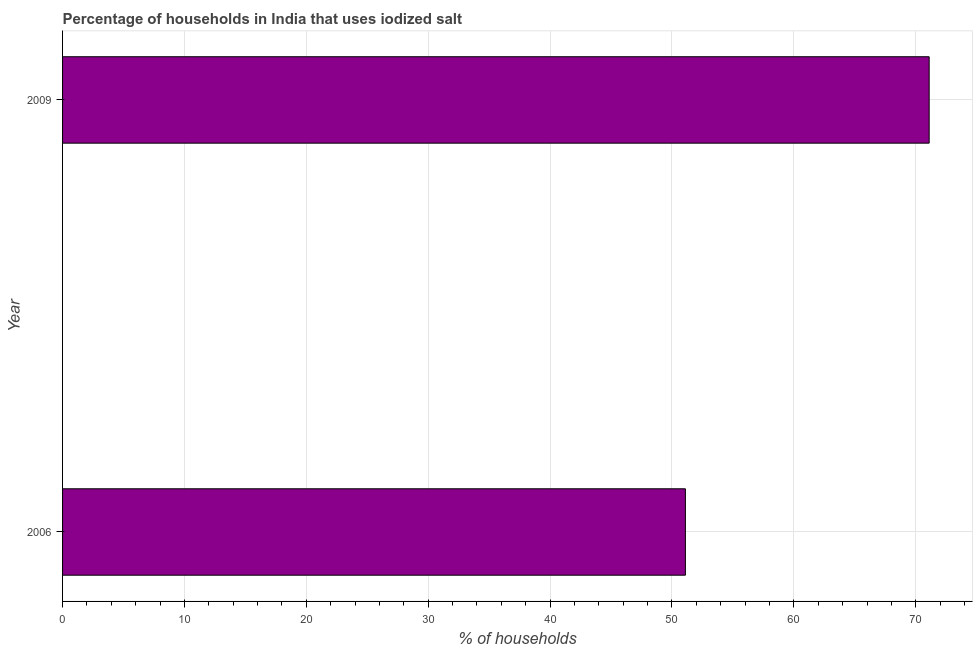Does the graph contain any zero values?
Your answer should be compact. No. Does the graph contain grids?
Ensure brevity in your answer.  Yes. What is the title of the graph?
Keep it short and to the point. Percentage of households in India that uses iodized salt. What is the label or title of the X-axis?
Keep it short and to the point. % of households. What is the label or title of the Y-axis?
Keep it short and to the point. Year. What is the percentage of households where iodized salt is consumed in 2006?
Offer a very short reply. 51.1. Across all years, what is the maximum percentage of households where iodized salt is consumed?
Your answer should be compact. 71.1. Across all years, what is the minimum percentage of households where iodized salt is consumed?
Keep it short and to the point. 51.1. What is the sum of the percentage of households where iodized salt is consumed?
Ensure brevity in your answer.  122.2. What is the average percentage of households where iodized salt is consumed per year?
Your answer should be very brief. 61.1. What is the median percentage of households where iodized salt is consumed?
Keep it short and to the point. 61.1. In how many years, is the percentage of households where iodized salt is consumed greater than 16 %?
Your response must be concise. 2. What is the ratio of the percentage of households where iodized salt is consumed in 2006 to that in 2009?
Make the answer very short. 0.72. How many bars are there?
Your answer should be very brief. 2. Are all the bars in the graph horizontal?
Your answer should be very brief. Yes. How many years are there in the graph?
Your answer should be compact. 2. What is the difference between two consecutive major ticks on the X-axis?
Your response must be concise. 10. What is the % of households of 2006?
Offer a very short reply. 51.1. What is the % of households of 2009?
Provide a succinct answer. 71.1. What is the ratio of the % of households in 2006 to that in 2009?
Your response must be concise. 0.72. 